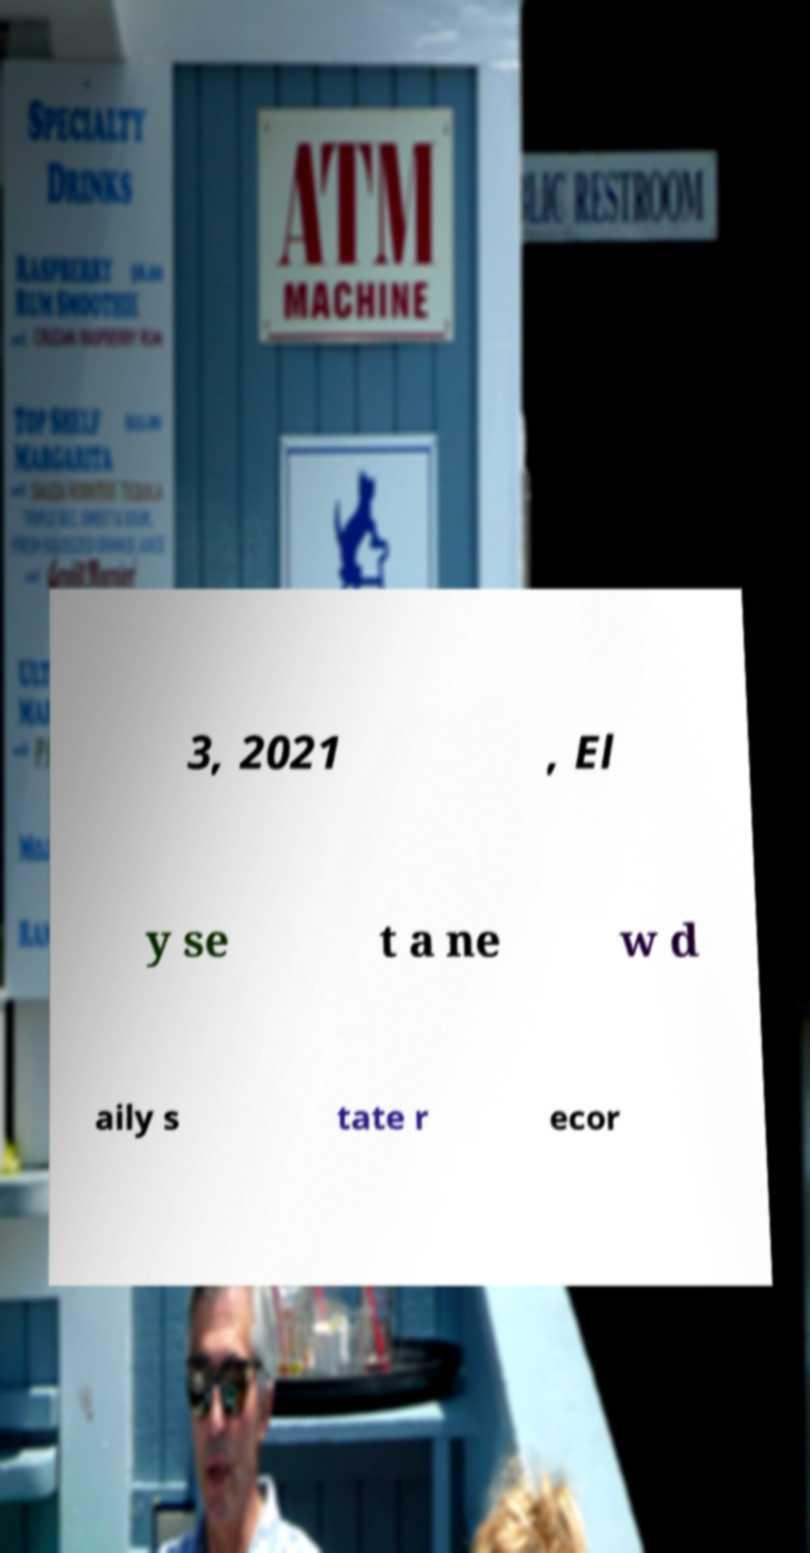Can you accurately transcribe the text from the provided image for me? 3, 2021 , El y se t a ne w d aily s tate r ecor 